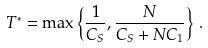<formula> <loc_0><loc_0><loc_500><loc_500>T ^ { * } = \max \left \{ \frac { 1 } { C _ { S } } , \frac { N } { C _ { S } + N C _ { 1 } } \right \} \, .</formula> 